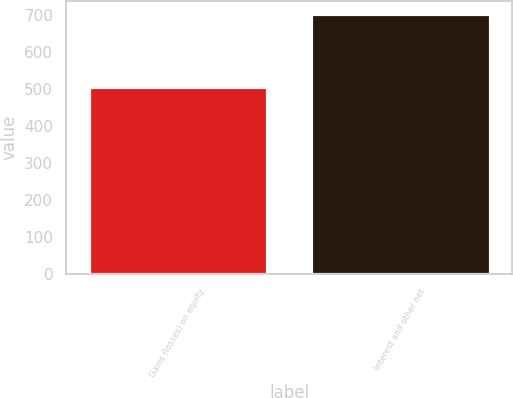<chart> <loc_0><loc_0><loc_500><loc_500><bar_chart><fcel>Gains (losses) on equity<fcel>Interest and other net<nl><fcel>506<fcel>703<nl></chart> 